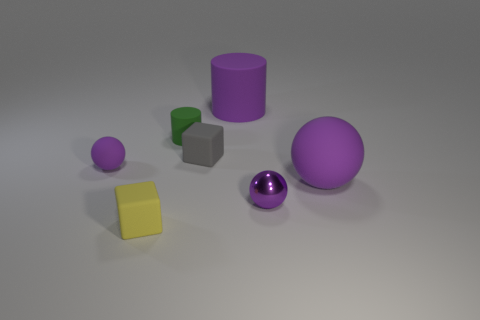How many purple balls must be subtracted to get 1 purple balls? 2 Add 3 purple metal things. How many objects exist? 10 Subtract all cubes. How many objects are left? 5 Subtract 0 gray cylinders. How many objects are left? 7 Subtract all big gray things. Subtract all matte spheres. How many objects are left? 5 Add 6 tiny gray matte cubes. How many tiny gray matte cubes are left? 7 Add 3 tiny yellow matte cubes. How many tiny yellow matte cubes exist? 4 